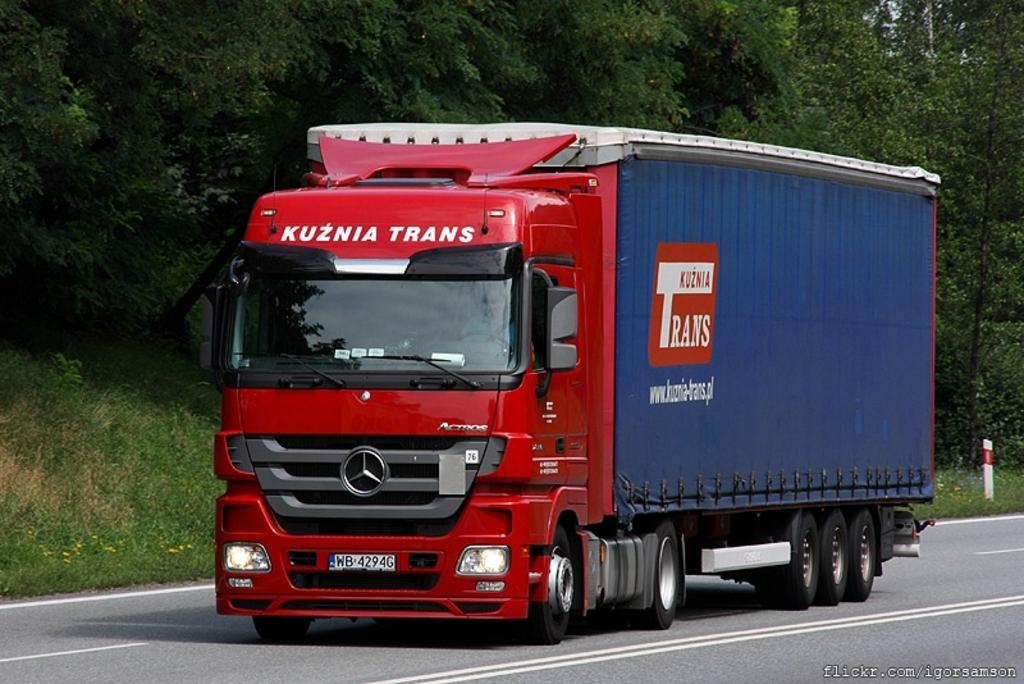What is the main subject of the image? There is a vehicle in the image. What is the vehicle doing in the image? The vehicle is moving on the road. What can be seen in the background of the image? There are plants and trees in the background of the image. Can you see any cobwebs hanging from the trees in the image? There is no mention of cobwebs in the image, so we cannot determine if any are present. 